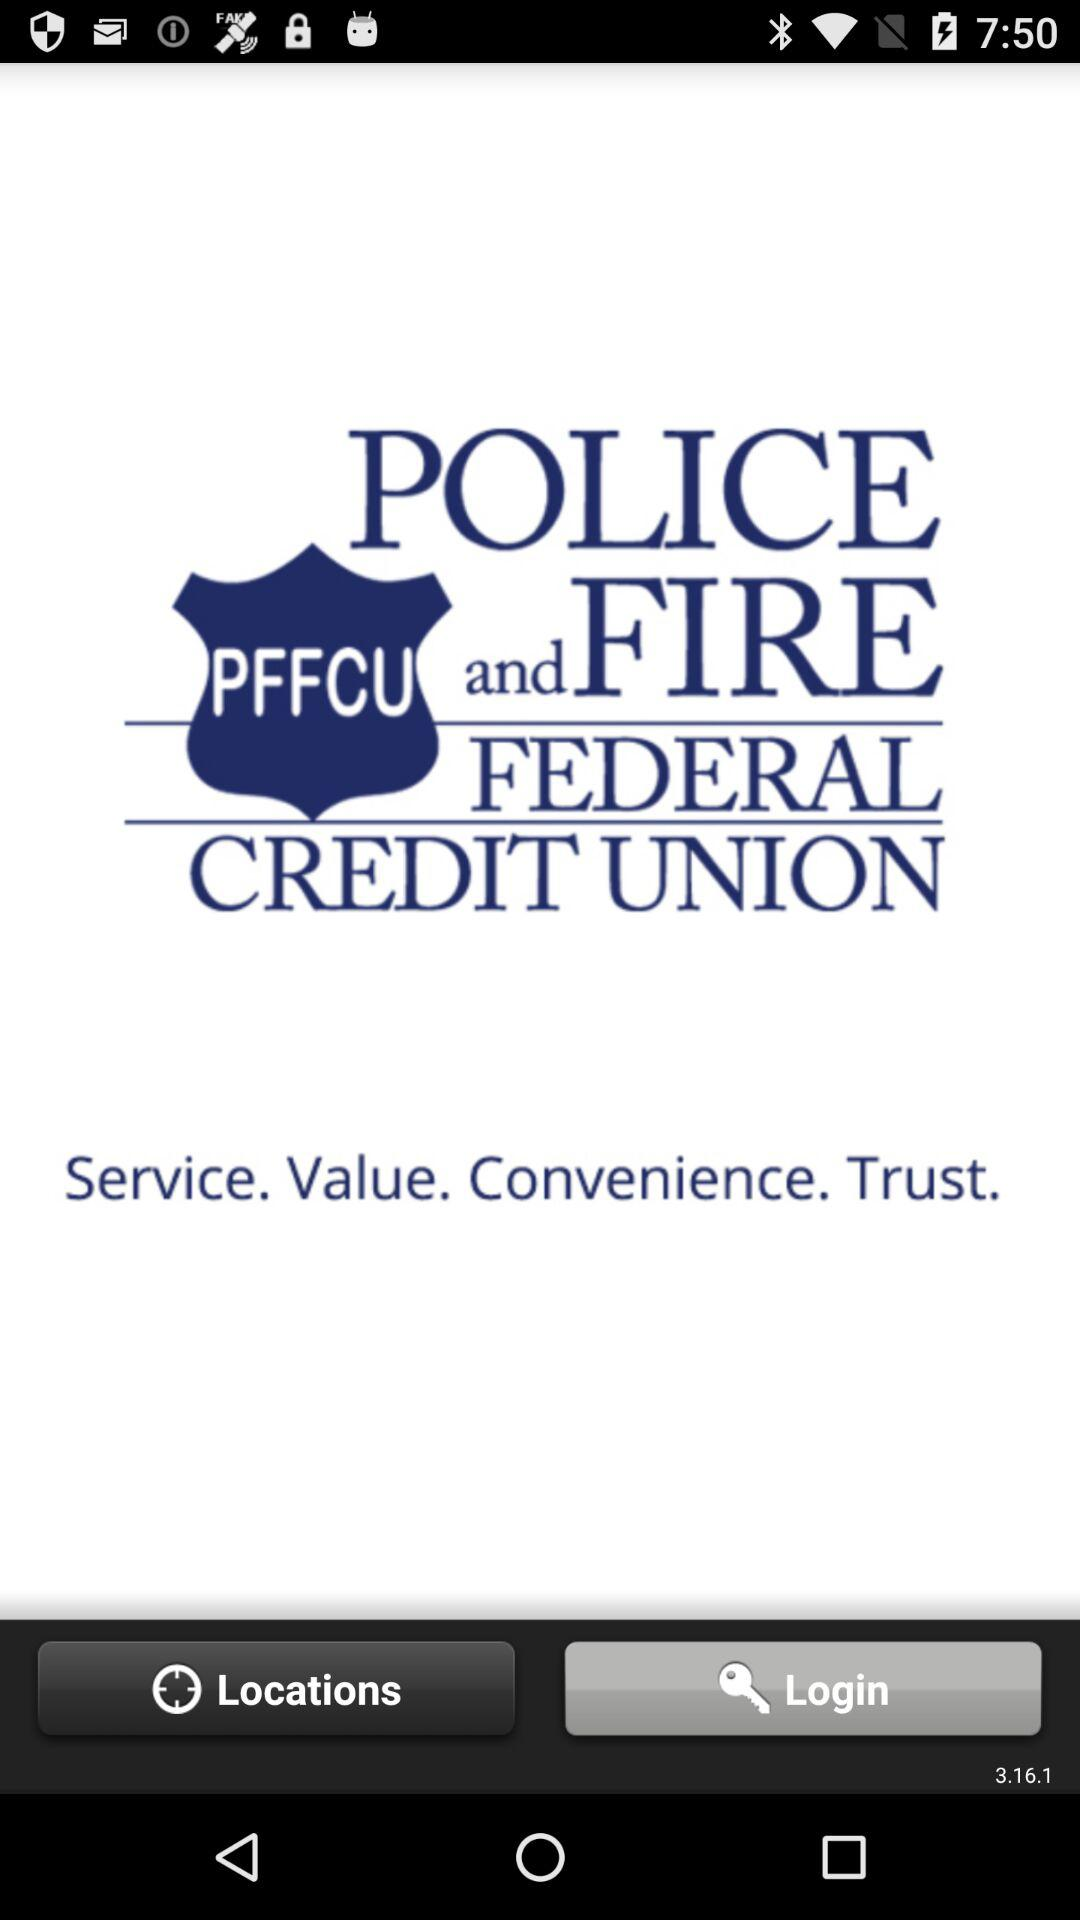What is the version number? The version number is 3.16.1. 